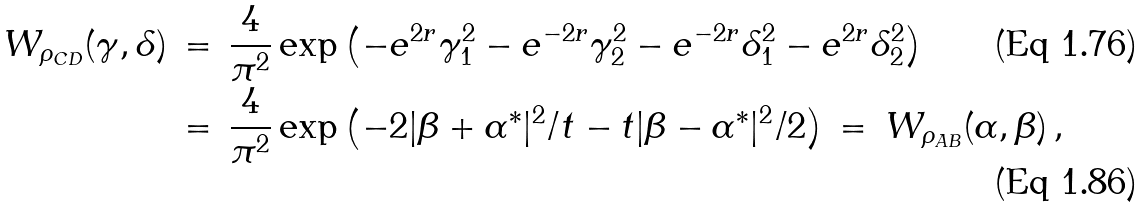Convert formula to latex. <formula><loc_0><loc_0><loc_500><loc_500>W _ { \rho _ { C D } } ( \gamma , \delta ) & \, = \, \frac { 4 } { \pi ^ { 2 } } \exp \left ( - e ^ { 2 r } \gamma _ { 1 } ^ { 2 } - e ^ { - 2 r } \gamma _ { 2 } ^ { 2 } - e ^ { - 2 r } \delta _ { 1 } ^ { 2 } - e ^ { 2 r } \delta _ { 2 } ^ { 2 } \right ) \\ & \, = \, \frac { 4 } { \pi ^ { 2 } } \exp \left ( - 2 | \beta + \alpha ^ { * } | ^ { 2 } / t - t | \beta - \alpha ^ { * } | ^ { 2 } / 2 \right ) \, = \, W _ { \rho _ { A B } } ( \alpha , \beta ) \, ,</formula> 